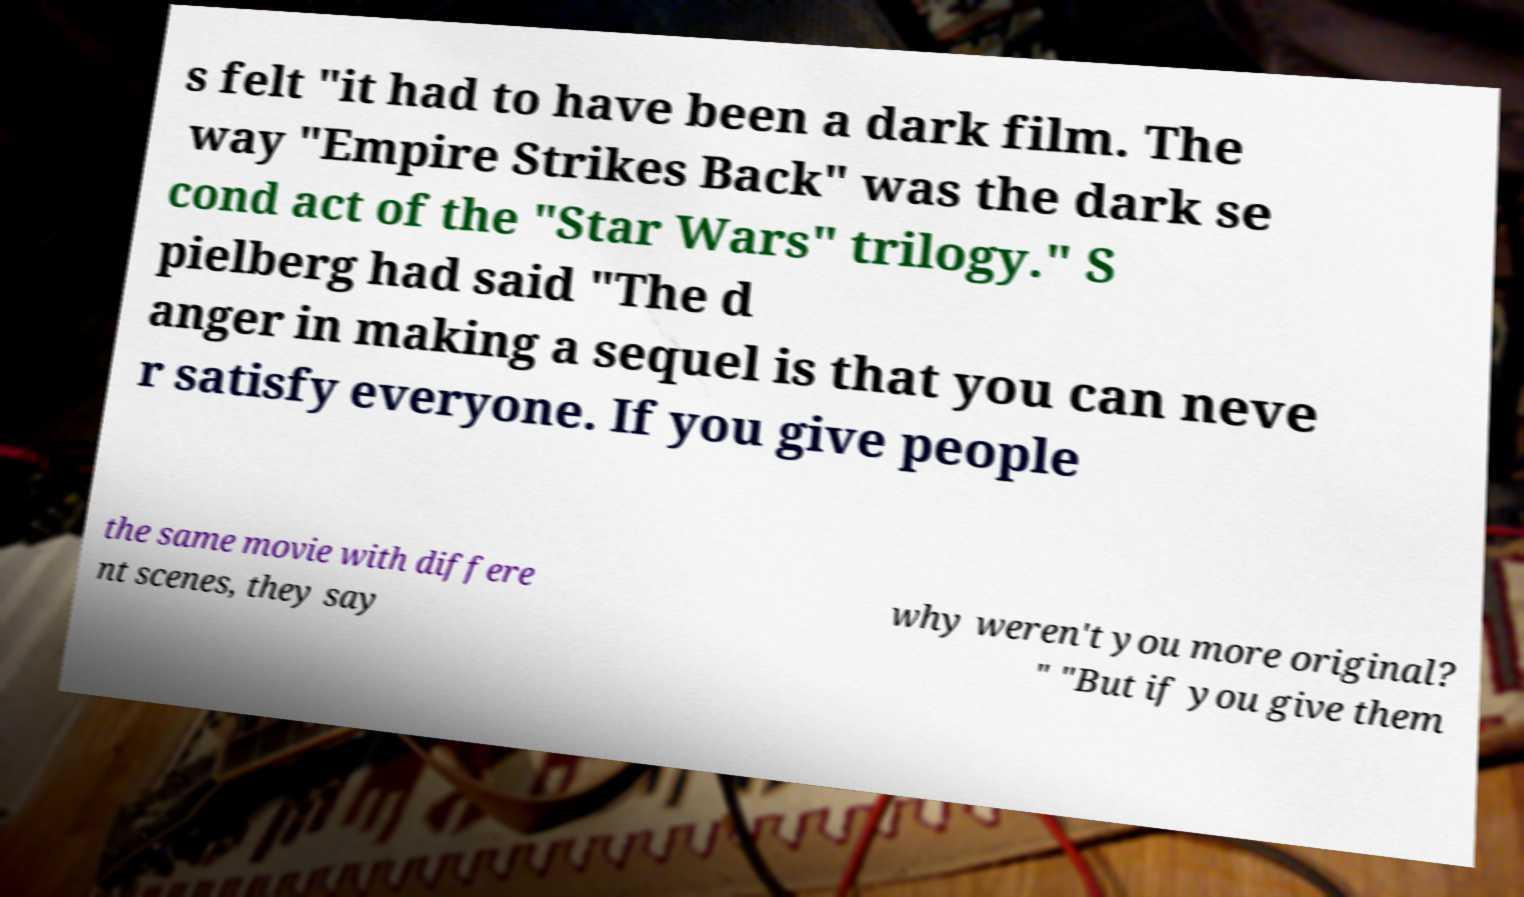Please identify and transcribe the text found in this image. s felt "it had to have been a dark film. The way "Empire Strikes Back" was the dark se cond act of the "Star Wars" trilogy." S pielberg had said "The d anger in making a sequel is that you can neve r satisfy everyone. If you give people the same movie with differe nt scenes, they say why weren't you more original? " "But if you give them 